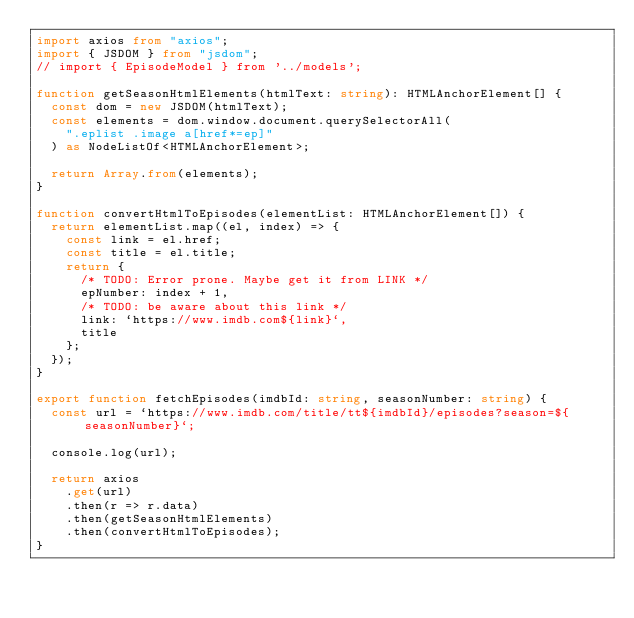<code> <loc_0><loc_0><loc_500><loc_500><_TypeScript_>import axios from "axios";
import { JSDOM } from "jsdom";
// import { EpisodeModel } from '../models';

function getSeasonHtmlElements(htmlText: string): HTMLAnchorElement[] {
  const dom = new JSDOM(htmlText);
  const elements = dom.window.document.querySelectorAll(
    ".eplist .image a[href*=ep]"
  ) as NodeListOf<HTMLAnchorElement>;

  return Array.from(elements);
}

function convertHtmlToEpisodes(elementList: HTMLAnchorElement[]) {
  return elementList.map((el, index) => {
    const link = el.href;
    const title = el.title;
    return {
      /* TODO: Error prone. Maybe get it from LINK */
      epNumber: index + 1,
      /* TODO: be aware about this link */
      link: `https://www.imdb.com${link}`,
      title
    };
  });
}

export function fetchEpisodes(imdbId: string, seasonNumber: string) {
  const url = `https://www.imdb.com/title/tt${imdbId}/episodes?season=${seasonNumber}`;

  console.log(url);

  return axios
    .get(url)
    .then(r => r.data)
    .then(getSeasonHtmlElements)
    .then(convertHtmlToEpisodes);
}
</code> 